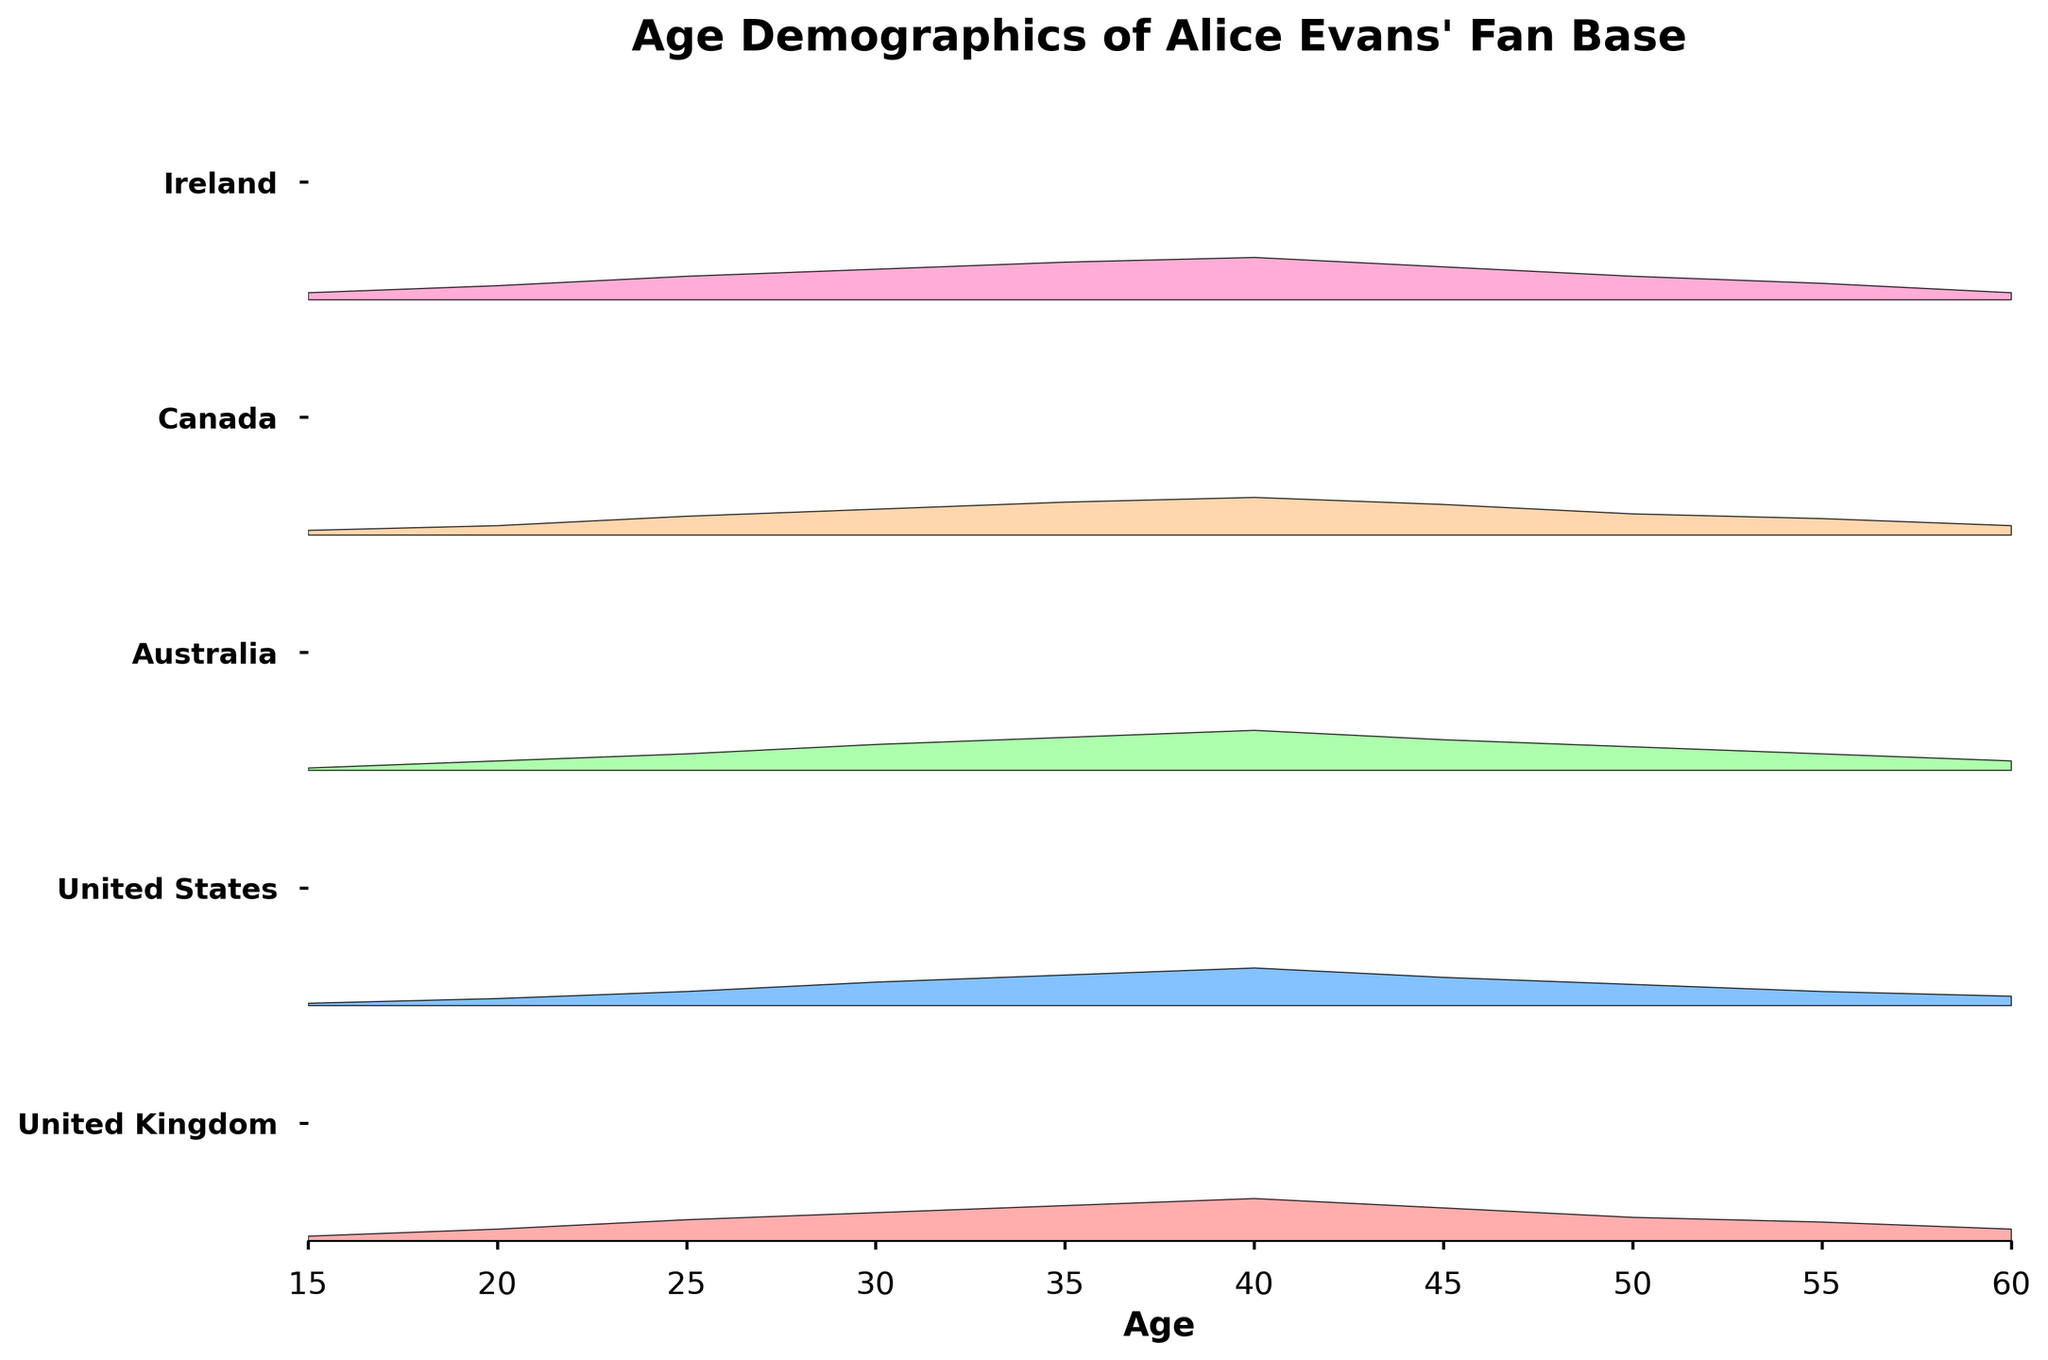Which country has the highest density of fans aged 40? The peak density for each age group is highlighted in the ridgeline plot. The density at age 40 in Ireland is 0.18, which is higher than in any other country.
Answer: Ireland What is the average fan density for people aged 25 across all countries? Add the density values for age 25 across all countries: 0.09 (UK) + 0.06 (US) + 0.07 (Australia) + 0.08 (Canada) + 0.10 (Ireland) = 0.40. Then divide by the number of countries: 0.40 / 5 = 0.08.
Answer: 0.08 Which age group has the lowest average density overall? Calculate the average density for each age group across all countries and compare them. The densities for age 15 are 0.02 (UK), 0.01 (US), 0.01 (Australia), 0.02 (Canada), and 0.03 (Ireland). The total is 0.09, and the average is 0.09 / 5 = 0.018, which is the lowest.
Answer: 15 Between Ireland and Australia, which country has more fans aged 30? Check the densities for age 30 in both countries. Ireland has a density of 0.13, while Australia has a density of 0.11. Hence, Ireland has more fans aged 30.
Answer: Ireland What age group in the United States has the highest density of fans? Identify the age group with the highest density in the ridgeline plot for the United States. The age group at 40 has the highest density of 0.16.
Answer: 40 Compare the density of fans aged 50 in the United Kingdom and Canada. Which country has a higher density? Look at the density at age 50 for both countries. The United Kingdom has a density of 0.10, while Canada has a density of 0.09. The United Kingdom has a higher density.
Answer: United Kingdom What is the sum of densities for fans aged 35 across all countries? Add the density values for age 35: 0.15 (UK) + 0.13 (US) + 0.14 (Australia) + 0.14 (Canada) + 0.16 (Ireland) = 0.72.
Answer: 0.72 Which country has the most evenly distributed fan base age demographics from age 15 to 60? Determine which country has the least variance in densities across all age groups. Reviewing the graph, the densities of Canada appear more consistent than other countries.
Answer: Canada How does the density of fans aged 55 in Australia compare to that of Ireland? Compare the densities at age 55 for both countries. Australia has a density of 0.07, while Ireland has a density of 0.07, making them equal.
Answer: Equal What is the combined density of fans aged 20 and 30 in the United Kingdom? Add the density values for ages 20 and 30: 0.05 (age 20) + 0.12 (age 30) = 0.17.
Answer: 0.17 